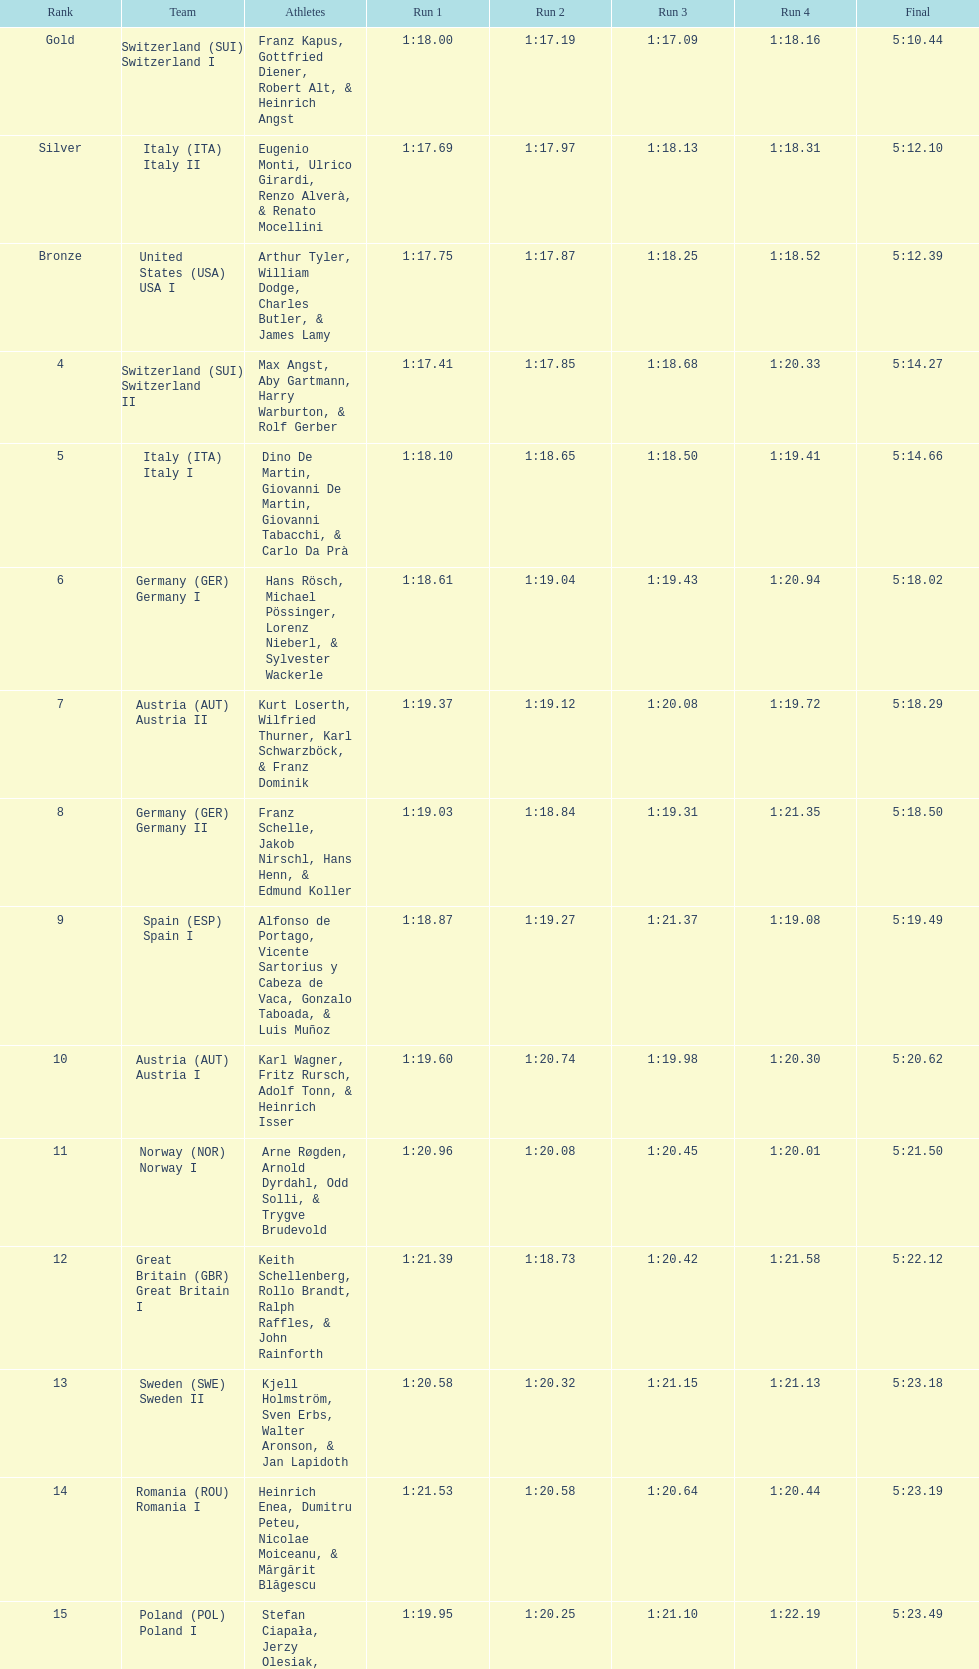What is the overall sum of runs? 4. 